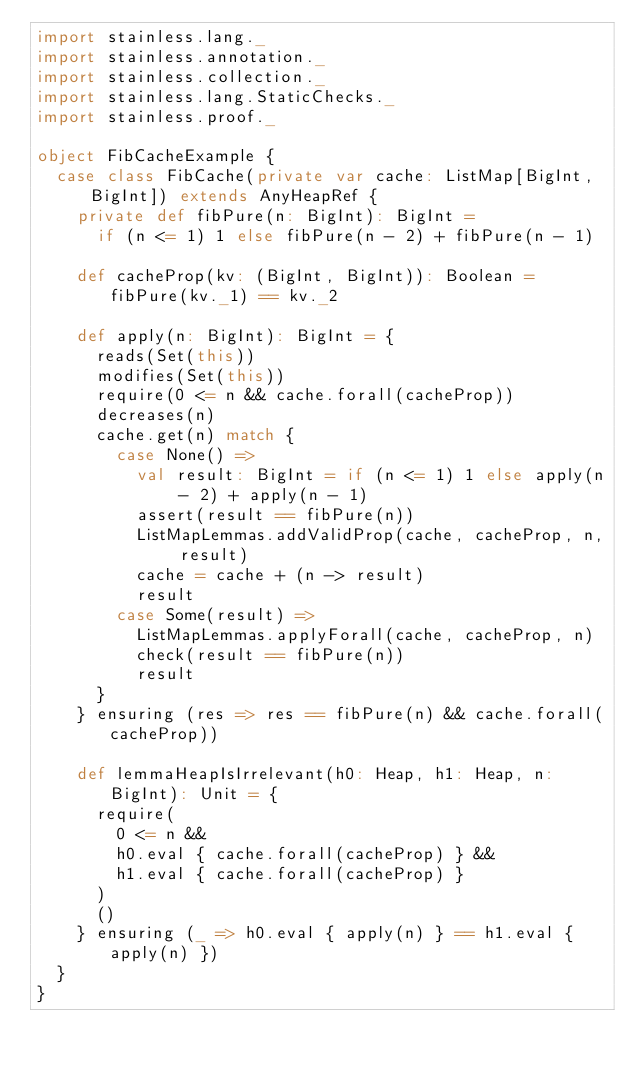Convert code to text. <code><loc_0><loc_0><loc_500><loc_500><_Scala_>import stainless.lang._
import stainless.annotation._
import stainless.collection._
import stainless.lang.StaticChecks._
import stainless.proof._

object FibCacheExample {
  case class FibCache(private var cache: ListMap[BigInt, BigInt]) extends AnyHeapRef {
    private def fibPure(n: BigInt): BigInt =
      if (n <= 1) 1 else fibPure(n - 2) + fibPure(n - 1)

    def cacheProp(kv: (BigInt, BigInt)): Boolean = fibPure(kv._1) == kv._2

    def apply(n: BigInt): BigInt = {
      reads(Set(this))
      modifies(Set(this))
      require(0 <= n && cache.forall(cacheProp))
      decreases(n)
      cache.get(n) match {
        case None() =>
          val result: BigInt = if (n <= 1) 1 else apply(n - 2) + apply(n - 1)
          assert(result == fibPure(n))
          ListMapLemmas.addValidProp(cache, cacheProp, n, result)
          cache = cache + (n -> result)
          result
        case Some(result) =>
          ListMapLemmas.applyForall(cache, cacheProp, n)
          check(result == fibPure(n))
          result
      }
    } ensuring (res => res == fibPure(n) && cache.forall(cacheProp))

    def lemmaHeapIsIrrelevant(h0: Heap, h1: Heap, n: BigInt): Unit = {
      require(
        0 <= n &&
        h0.eval { cache.forall(cacheProp) } &&
        h1.eval { cache.forall(cacheProp) }
      )
      ()
    } ensuring (_ => h0.eval { apply(n) } == h1.eval { apply(n) })
  }
}
</code> 